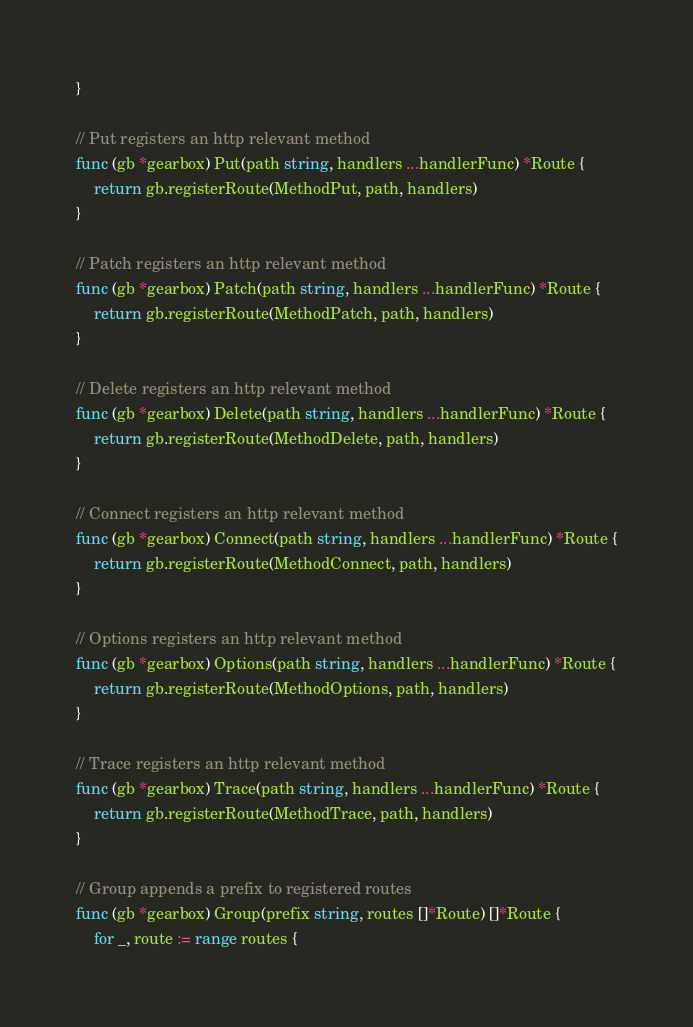Convert code to text. <code><loc_0><loc_0><loc_500><loc_500><_Go_>}

// Put registers an http relevant method
func (gb *gearbox) Put(path string, handlers ...handlerFunc) *Route {
	return gb.registerRoute(MethodPut, path, handlers)
}

// Patch registers an http relevant method
func (gb *gearbox) Patch(path string, handlers ...handlerFunc) *Route {
	return gb.registerRoute(MethodPatch, path, handlers)
}

// Delete registers an http relevant method
func (gb *gearbox) Delete(path string, handlers ...handlerFunc) *Route {
	return gb.registerRoute(MethodDelete, path, handlers)
}

// Connect registers an http relevant method
func (gb *gearbox) Connect(path string, handlers ...handlerFunc) *Route {
	return gb.registerRoute(MethodConnect, path, handlers)
}

// Options registers an http relevant method
func (gb *gearbox) Options(path string, handlers ...handlerFunc) *Route {
	return gb.registerRoute(MethodOptions, path, handlers)
}

// Trace registers an http relevant method
func (gb *gearbox) Trace(path string, handlers ...handlerFunc) *Route {
	return gb.registerRoute(MethodTrace, path, handlers)
}

// Group appends a prefix to registered routes
func (gb *gearbox) Group(prefix string, routes []*Route) []*Route {
	for _, route := range routes {</code> 